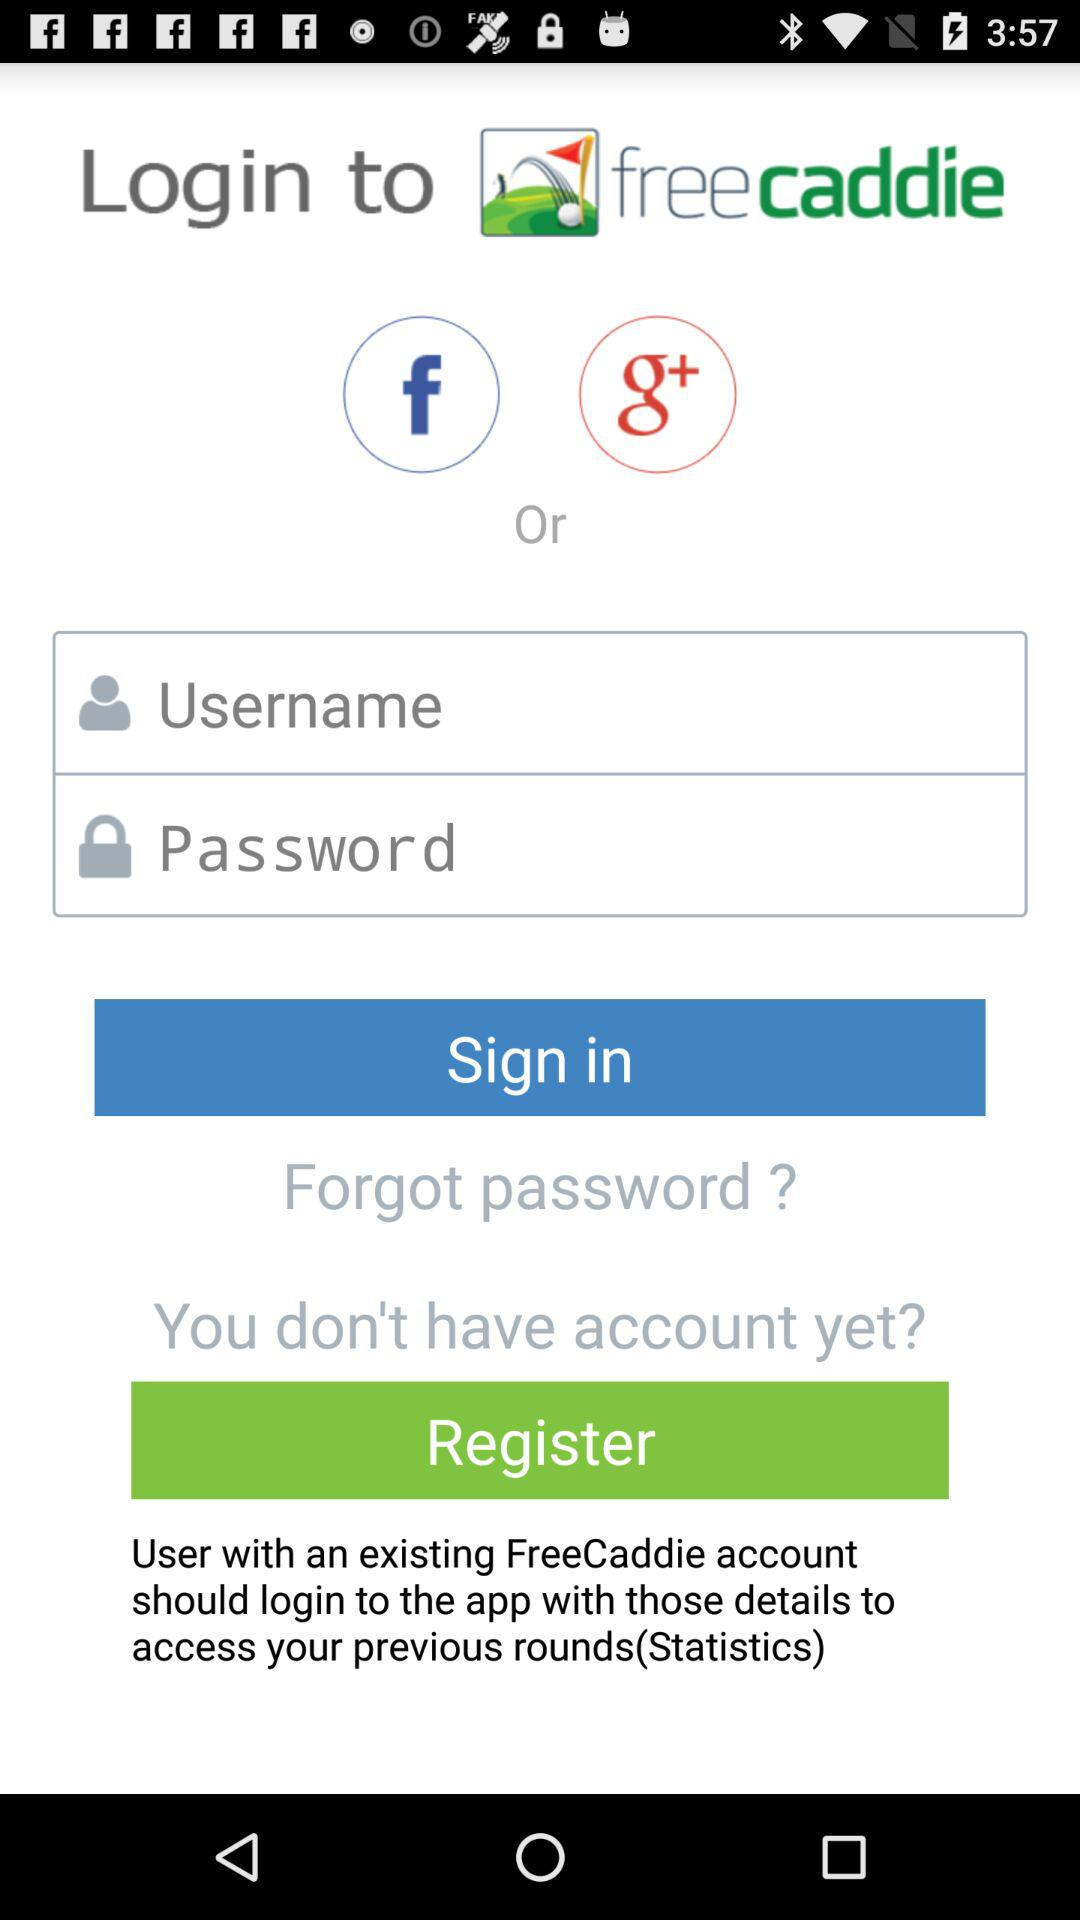How many different ways can I sign in to FreeCaddie?
Answer the question using a single word or phrase. 3 